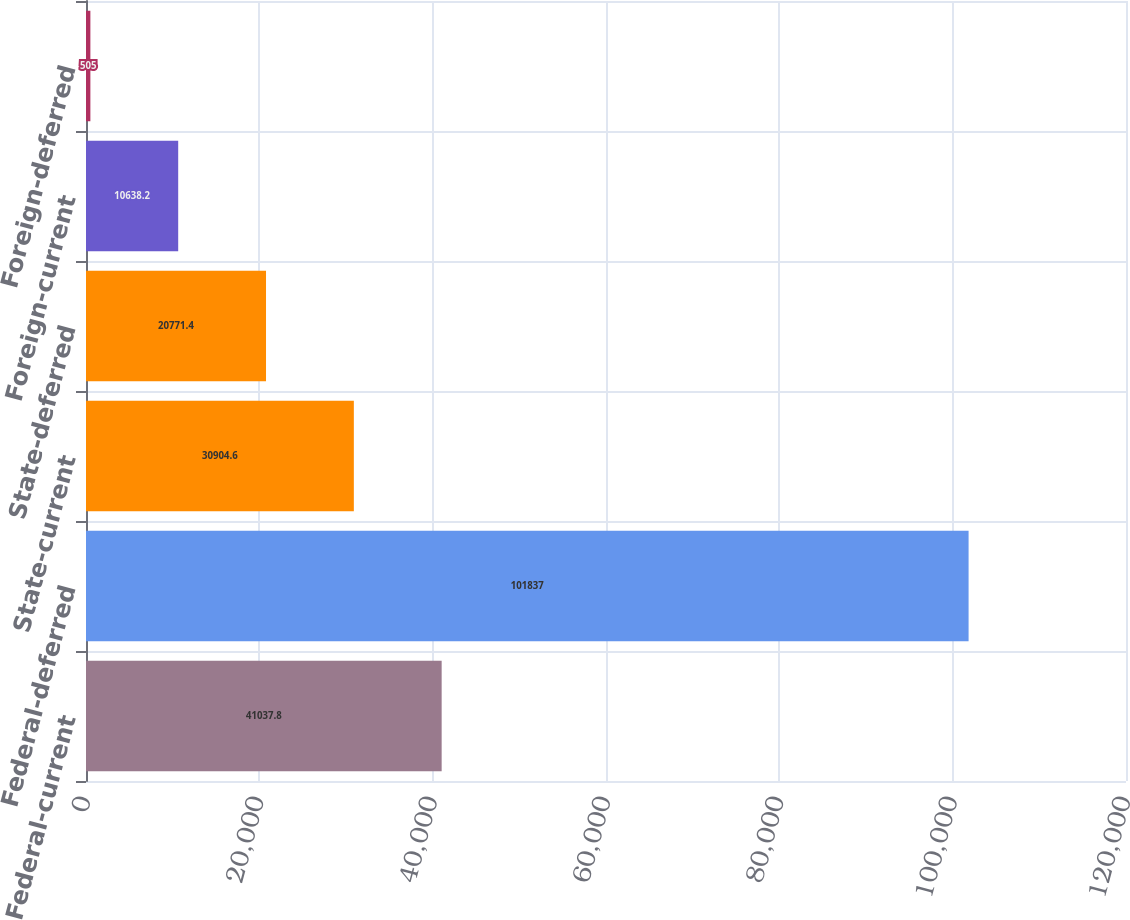Convert chart to OTSL. <chart><loc_0><loc_0><loc_500><loc_500><bar_chart><fcel>Federal-current<fcel>Federal-deferred<fcel>State-current<fcel>State-deferred<fcel>Foreign-current<fcel>Foreign-deferred<nl><fcel>41037.8<fcel>101837<fcel>30904.6<fcel>20771.4<fcel>10638.2<fcel>505<nl></chart> 